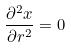<formula> <loc_0><loc_0><loc_500><loc_500>\frac { \partial ^ { 2 } x } { \partial r ^ { 2 } } = 0</formula> 